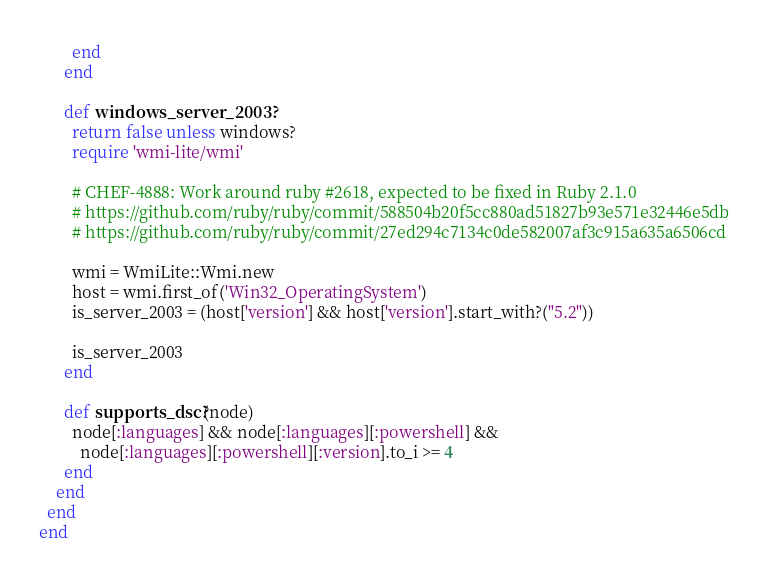<code> <loc_0><loc_0><loc_500><loc_500><_Ruby_>        end
      end

      def windows_server_2003?
        return false unless windows?
        require 'wmi-lite/wmi'

        # CHEF-4888: Work around ruby #2618, expected to be fixed in Ruby 2.1.0
        # https://github.com/ruby/ruby/commit/588504b20f5cc880ad51827b93e571e32446e5db
        # https://github.com/ruby/ruby/commit/27ed294c7134c0de582007af3c915a635a6506cd

        wmi = WmiLite::Wmi.new
        host = wmi.first_of('Win32_OperatingSystem')
        is_server_2003 = (host['version'] && host['version'].start_with?("5.2"))

        is_server_2003
      end

      def supports_dsc?(node)
        node[:languages] && node[:languages][:powershell] &&
          node[:languages][:powershell][:version].to_i >= 4
      end
    end
  end
end
</code> 